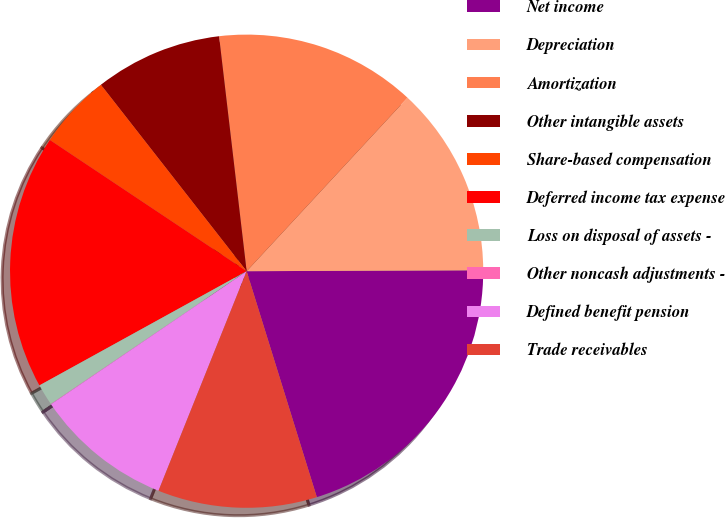Convert chart. <chart><loc_0><loc_0><loc_500><loc_500><pie_chart><fcel>Net income<fcel>Depreciation<fcel>Amortization<fcel>Other intangible assets<fcel>Share-based compensation<fcel>Deferred income tax expense<fcel>Loss on disposal of assets -<fcel>Other noncash adjustments -<fcel>Defined benefit pension<fcel>Trade receivables<nl><fcel>20.27%<fcel>13.04%<fcel>13.76%<fcel>8.7%<fcel>5.08%<fcel>17.38%<fcel>1.47%<fcel>0.02%<fcel>9.42%<fcel>10.87%<nl></chart> 